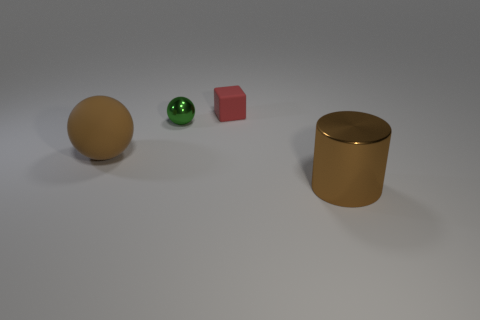Add 1 big yellow shiny things. How many objects exist? 5 Subtract all cylinders. How many objects are left? 3 Subtract all large gray rubber things. Subtract all small shiny spheres. How many objects are left? 3 Add 4 small rubber cubes. How many small rubber cubes are left? 5 Add 1 tiny gray cylinders. How many tiny gray cylinders exist? 1 Subtract 0 green cylinders. How many objects are left? 4 